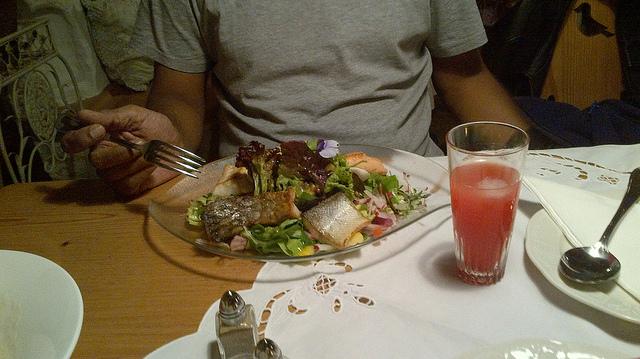What color is the plate?
Answer briefly. Clear. Is the drink on the table hot or cold?
Write a very short answer. Cold. What color are the salt and pepper shakers?
Concise answer only. Clear. Do you need a fork and a knife to eat a salad?
Concise answer only. Yes. How many ways has the sandwich been cut?
Concise answer only. 0. IS there a child's cup present?
Write a very short answer. No. Do people typically eat this food with their hands?
Answer briefly. No. What is going on here?
Concise answer only. Eating. How many prongs does the fork have?
Give a very brief answer. 4. How many plates of food are sitting on this white table?
Quick response, please. 1. What type of plant is this?
Be succinct. Lettuce. What shape is the plate?
Write a very short answer. Oval. Are they sharing?
Write a very short answer. No. What color are the dishes?
Keep it brief. Clear. What color is the drink?
Write a very short answer. Pink. What utensil is being used to eat the food?
Answer briefly. Fork. Do you find meat in the salad?
Short answer required. Yes. How many serving utensils are on the table?
Give a very brief answer. 2. Is the food raw?
Answer briefly. Yes. How many straws in the picture?
Short answer required. 0. What utensil is on the plate?
Keep it brief. Spoon. Is this an example of 'fine dining'?
Write a very short answer. No. What is the green food?
Short answer required. Salad. What kind of beverage is in the glasses?
Concise answer only. Juice. Is one of the glasses half full of orange juice?
Quick response, please. No. Has dinner started yet?
Give a very brief answer. Yes. Is this an acceptable meal?
Short answer required. Yes. Is this salad healthy?
Be succinct. Yes. What are they drinking?
Be succinct. Juice. 